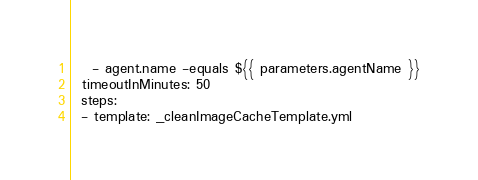Convert code to text. <code><loc_0><loc_0><loc_500><loc_500><_YAML_>    - agent.name -equals ${{ parameters.agentName }}
  timeoutInMinutes: 50
  steps:
  - template: _cleanImageCacheTemplate.yml
</code> 